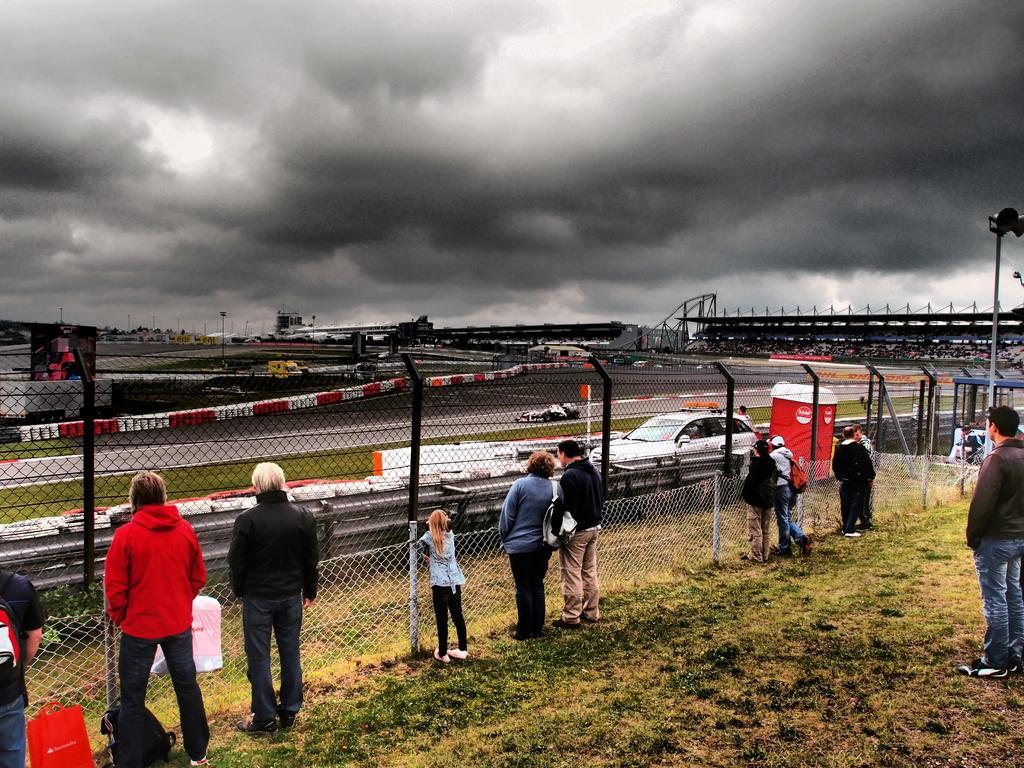Could you give a brief overview of what you see in this image? In the picture we can see the part of the grass surface on it, we can see some people are standing near the fence and watching the race and in the background we can see the sky with clouds. 